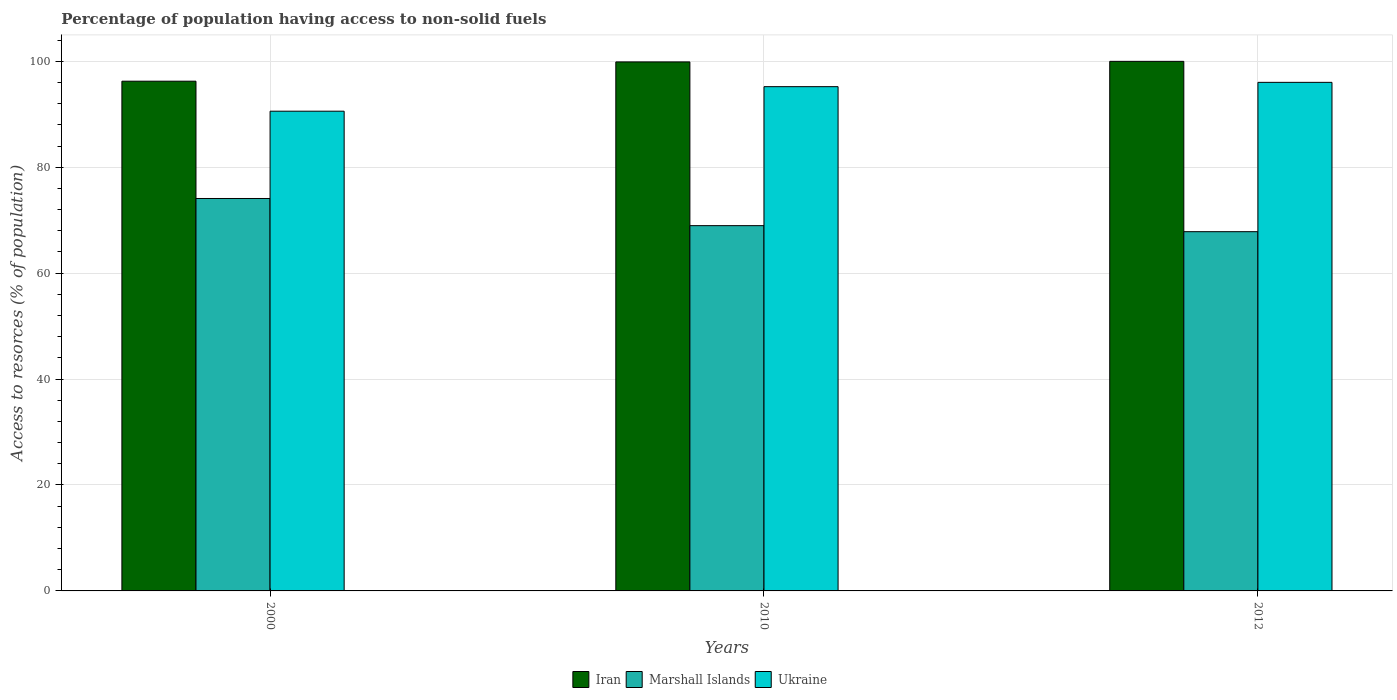How many different coloured bars are there?
Your answer should be very brief. 3. Are the number of bars per tick equal to the number of legend labels?
Give a very brief answer. Yes. Are the number of bars on each tick of the X-axis equal?
Offer a very short reply. Yes. How many bars are there on the 1st tick from the right?
Offer a very short reply. 3. What is the label of the 2nd group of bars from the left?
Offer a terse response. 2010. What is the percentage of population having access to non-solid fuels in Marshall Islands in 2010?
Give a very brief answer. 68.97. Across all years, what is the maximum percentage of population having access to non-solid fuels in Marshall Islands?
Your response must be concise. 74.09. Across all years, what is the minimum percentage of population having access to non-solid fuels in Ukraine?
Your response must be concise. 90.58. In which year was the percentage of population having access to non-solid fuels in Iran maximum?
Your response must be concise. 2012. What is the total percentage of population having access to non-solid fuels in Iran in the graph?
Offer a very short reply. 296.11. What is the difference between the percentage of population having access to non-solid fuels in Ukraine in 2000 and that in 2012?
Ensure brevity in your answer.  -5.45. What is the difference between the percentage of population having access to non-solid fuels in Ukraine in 2010 and the percentage of population having access to non-solid fuels in Marshall Islands in 2012?
Your answer should be very brief. 27.38. What is the average percentage of population having access to non-solid fuels in Iran per year?
Provide a succinct answer. 98.7. In the year 2012, what is the difference between the percentage of population having access to non-solid fuels in Iran and percentage of population having access to non-solid fuels in Ukraine?
Your answer should be very brief. 3.97. In how many years, is the percentage of population having access to non-solid fuels in Ukraine greater than 60 %?
Your answer should be very brief. 3. What is the ratio of the percentage of population having access to non-solid fuels in Marshall Islands in 2010 to that in 2012?
Provide a succinct answer. 1.02. Is the percentage of population having access to non-solid fuels in Marshall Islands in 2000 less than that in 2010?
Make the answer very short. No. What is the difference between the highest and the second highest percentage of population having access to non-solid fuels in Marshall Islands?
Ensure brevity in your answer.  5.13. What is the difference between the highest and the lowest percentage of population having access to non-solid fuels in Iran?
Give a very brief answer. 3.75. In how many years, is the percentage of population having access to non-solid fuels in Ukraine greater than the average percentage of population having access to non-solid fuels in Ukraine taken over all years?
Make the answer very short. 2. Is the sum of the percentage of population having access to non-solid fuels in Marshall Islands in 2000 and 2010 greater than the maximum percentage of population having access to non-solid fuels in Iran across all years?
Provide a succinct answer. Yes. What does the 3rd bar from the left in 2000 represents?
Keep it short and to the point. Ukraine. What does the 1st bar from the right in 2000 represents?
Give a very brief answer. Ukraine. How many bars are there?
Give a very brief answer. 9. Are all the bars in the graph horizontal?
Your answer should be compact. No. What is the difference between two consecutive major ticks on the Y-axis?
Your answer should be very brief. 20. Are the values on the major ticks of Y-axis written in scientific E-notation?
Offer a terse response. No. How many legend labels are there?
Give a very brief answer. 3. How are the legend labels stacked?
Provide a succinct answer. Horizontal. What is the title of the graph?
Give a very brief answer. Percentage of population having access to non-solid fuels. Does "Nepal" appear as one of the legend labels in the graph?
Give a very brief answer. No. What is the label or title of the Y-axis?
Offer a terse response. Access to resorces (% of population). What is the Access to resorces (% of population) in Iran in 2000?
Ensure brevity in your answer.  96.24. What is the Access to resorces (% of population) in Marshall Islands in 2000?
Offer a very short reply. 74.09. What is the Access to resorces (% of population) in Ukraine in 2000?
Give a very brief answer. 90.58. What is the Access to resorces (% of population) in Iran in 2010?
Provide a succinct answer. 99.88. What is the Access to resorces (% of population) in Marshall Islands in 2010?
Offer a very short reply. 68.97. What is the Access to resorces (% of population) in Ukraine in 2010?
Offer a terse response. 95.21. What is the Access to resorces (% of population) in Iran in 2012?
Provide a short and direct response. 99.99. What is the Access to resorces (% of population) of Marshall Islands in 2012?
Keep it short and to the point. 67.83. What is the Access to resorces (% of population) of Ukraine in 2012?
Keep it short and to the point. 96.02. Across all years, what is the maximum Access to resorces (% of population) of Iran?
Offer a terse response. 99.99. Across all years, what is the maximum Access to resorces (% of population) in Marshall Islands?
Your response must be concise. 74.09. Across all years, what is the maximum Access to resorces (% of population) of Ukraine?
Provide a short and direct response. 96.02. Across all years, what is the minimum Access to resorces (% of population) of Iran?
Keep it short and to the point. 96.24. Across all years, what is the minimum Access to resorces (% of population) of Marshall Islands?
Make the answer very short. 67.83. Across all years, what is the minimum Access to resorces (% of population) in Ukraine?
Make the answer very short. 90.58. What is the total Access to resorces (% of population) of Iran in the graph?
Make the answer very short. 296.11. What is the total Access to resorces (% of population) of Marshall Islands in the graph?
Ensure brevity in your answer.  210.89. What is the total Access to resorces (% of population) in Ukraine in the graph?
Your answer should be very brief. 281.8. What is the difference between the Access to resorces (% of population) of Iran in 2000 and that in 2010?
Your answer should be compact. -3.64. What is the difference between the Access to resorces (% of population) of Marshall Islands in 2000 and that in 2010?
Provide a short and direct response. 5.13. What is the difference between the Access to resorces (% of population) in Ukraine in 2000 and that in 2010?
Offer a very short reply. -4.63. What is the difference between the Access to resorces (% of population) of Iran in 2000 and that in 2012?
Your answer should be very brief. -3.75. What is the difference between the Access to resorces (% of population) of Marshall Islands in 2000 and that in 2012?
Ensure brevity in your answer.  6.27. What is the difference between the Access to resorces (% of population) in Ukraine in 2000 and that in 2012?
Provide a succinct answer. -5.45. What is the difference between the Access to resorces (% of population) in Iran in 2010 and that in 2012?
Keep it short and to the point. -0.11. What is the difference between the Access to resorces (% of population) of Marshall Islands in 2010 and that in 2012?
Your response must be concise. 1.14. What is the difference between the Access to resorces (% of population) of Ukraine in 2010 and that in 2012?
Offer a terse response. -0.81. What is the difference between the Access to resorces (% of population) in Iran in 2000 and the Access to resorces (% of population) in Marshall Islands in 2010?
Your answer should be very brief. 27.27. What is the difference between the Access to resorces (% of population) of Iran in 2000 and the Access to resorces (% of population) of Ukraine in 2010?
Your answer should be compact. 1.03. What is the difference between the Access to resorces (% of population) of Marshall Islands in 2000 and the Access to resorces (% of population) of Ukraine in 2010?
Provide a short and direct response. -21.11. What is the difference between the Access to resorces (% of population) in Iran in 2000 and the Access to resorces (% of population) in Marshall Islands in 2012?
Provide a succinct answer. 28.41. What is the difference between the Access to resorces (% of population) in Iran in 2000 and the Access to resorces (% of population) in Ukraine in 2012?
Provide a short and direct response. 0.22. What is the difference between the Access to resorces (% of population) in Marshall Islands in 2000 and the Access to resorces (% of population) in Ukraine in 2012?
Your answer should be very brief. -21.93. What is the difference between the Access to resorces (% of population) of Iran in 2010 and the Access to resorces (% of population) of Marshall Islands in 2012?
Keep it short and to the point. 32.05. What is the difference between the Access to resorces (% of population) in Iran in 2010 and the Access to resorces (% of population) in Ukraine in 2012?
Give a very brief answer. 3.86. What is the difference between the Access to resorces (% of population) of Marshall Islands in 2010 and the Access to resorces (% of population) of Ukraine in 2012?
Provide a succinct answer. -27.05. What is the average Access to resorces (% of population) of Iran per year?
Offer a terse response. 98.7. What is the average Access to resorces (% of population) in Marshall Islands per year?
Give a very brief answer. 70.3. What is the average Access to resorces (% of population) in Ukraine per year?
Provide a short and direct response. 93.93. In the year 2000, what is the difference between the Access to resorces (% of population) of Iran and Access to resorces (% of population) of Marshall Islands?
Offer a very short reply. 22.15. In the year 2000, what is the difference between the Access to resorces (% of population) in Iran and Access to resorces (% of population) in Ukraine?
Ensure brevity in your answer.  5.66. In the year 2000, what is the difference between the Access to resorces (% of population) of Marshall Islands and Access to resorces (% of population) of Ukraine?
Your answer should be very brief. -16.48. In the year 2010, what is the difference between the Access to resorces (% of population) of Iran and Access to resorces (% of population) of Marshall Islands?
Make the answer very short. 30.91. In the year 2010, what is the difference between the Access to resorces (% of population) in Iran and Access to resorces (% of population) in Ukraine?
Make the answer very short. 4.67. In the year 2010, what is the difference between the Access to resorces (% of population) in Marshall Islands and Access to resorces (% of population) in Ukraine?
Offer a terse response. -26.24. In the year 2012, what is the difference between the Access to resorces (% of population) in Iran and Access to resorces (% of population) in Marshall Islands?
Give a very brief answer. 32.16. In the year 2012, what is the difference between the Access to resorces (% of population) of Iran and Access to resorces (% of population) of Ukraine?
Your response must be concise. 3.97. In the year 2012, what is the difference between the Access to resorces (% of population) in Marshall Islands and Access to resorces (% of population) in Ukraine?
Your response must be concise. -28.19. What is the ratio of the Access to resorces (% of population) in Iran in 2000 to that in 2010?
Your response must be concise. 0.96. What is the ratio of the Access to resorces (% of population) in Marshall Islands in 2000 to that in 2010?
Make the answer very short. 1.07. What is the ratio of the Access to resorces (% of population) of Ukraine in 2000 to that in 2010?
Your answer should be very brief. 0.95. What is the ratio of the Access to resorces (% of population) in Iran in 2000 to that in 2012?
Keep it short and to the point. 0.96. What is the ratio of the Access to resorces (% of population) in Marshall Islands in 2000 to that in 2012?
Provide a succinct answer. 1.09. What is the ratio of the Access to resorces (% of population) of Ukraine in 2000 to that in 2012?
Offer a very short reply. 0.94. What is the ratio of the Access to resorces (% of population) in Iran in 2010 to that in 2012?
Give a very brief answer. 1. What is the ratio of the Access to resorces (% of population) in Marshall Islands in 2010 to that in 2012?
Your answer should be very brief. 1.02. What is the difference between the highest and the second highest Access to resorces (% of population) in Iran?
Provide a short and direct response. 0.11. What is the difference between the highest and the second highest Access to resorces (% of population) of Marshall Islands?
Give a very brief answer. 5.13. What is the difference between the highest and the second highest Access to resorces (% of population) of Ukraine?
Your answer should be compact. 0.81. What is the difference between the highest and the lowest Access to resorces (% of population) of Iran?
Keep it short and to the point. 3.75. What is the difference between the highest and the lowest Access to resorces (% of population) in Marshall Islands?
Provide a short and direct response. 6.27. What is the difference between the highest and the lowest Access to resorces (% of population) of Ukraine?
Ensure brevity in your answer.  5.45. 